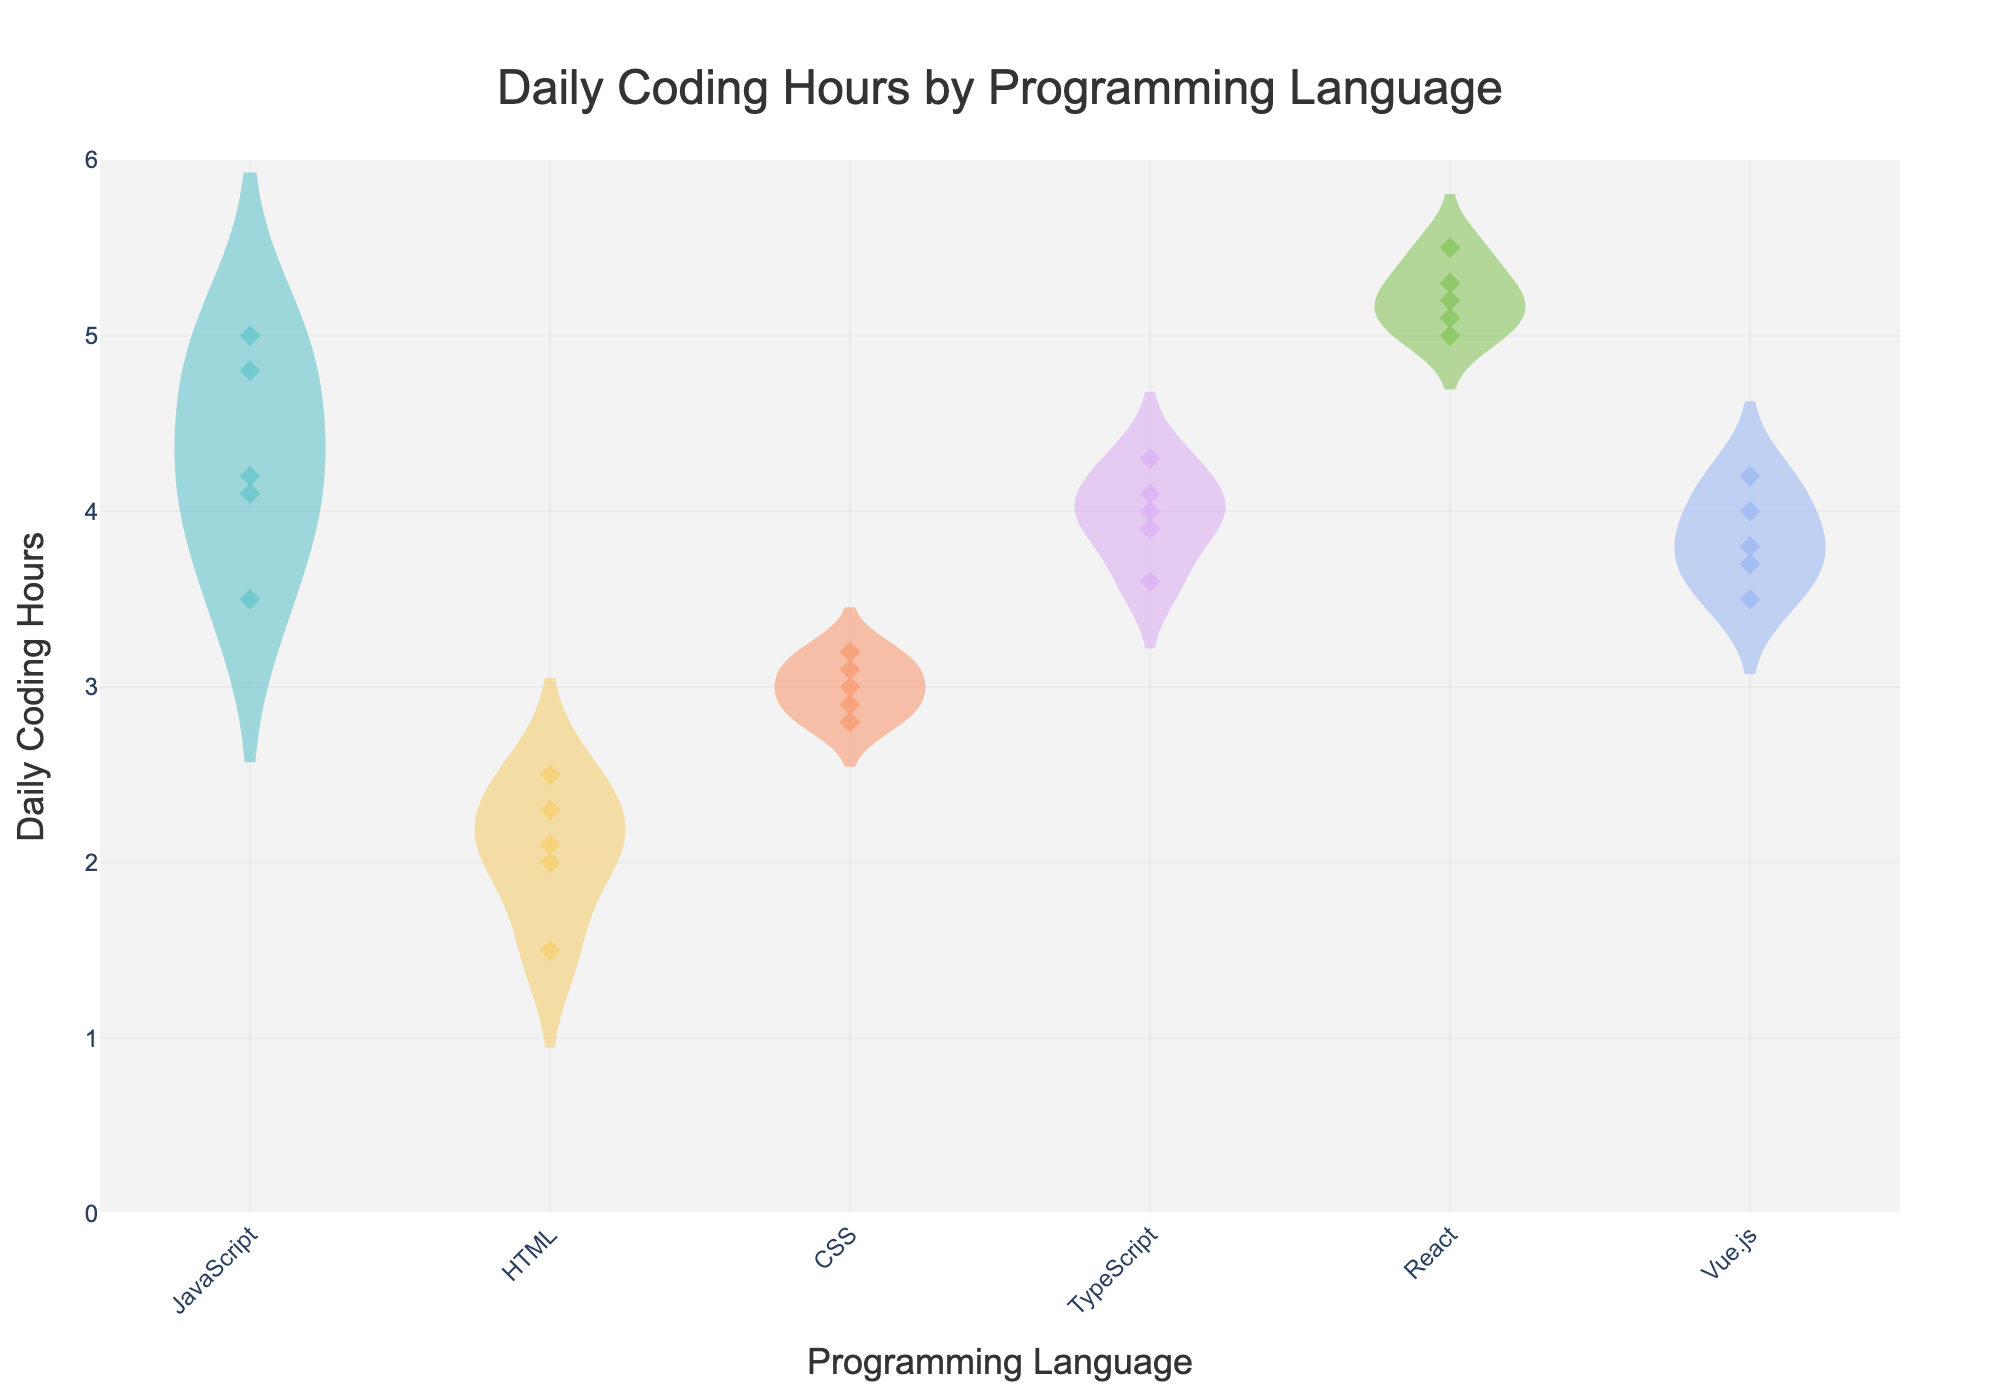What's the title of the figure? The title of the figure is displayed at the top center. It reads "Daily Coding Hours by Programming Language".
Answer: Daily Coding Hours by Programming Language Which programming language(s) has the highest median daily coding hours? The median daily coding hours are visualized by the horizontal line inside the violin plot. The React programming language's violin plot has the highest horizontal line indicating the highest median value.
Answer: React How many data points are there for JavaScript? Each dot represents a data point. Counting the dots for JavaScript, we see there are five dots.
Answer: 5 What is the range of daily coding hours for Vue.js? The range in the violin plot is the difference between the maximum and minimum values. For Vue.js, the violin plot extends from around 3.5 to 4.2 daily coding hours.
Answer: 3.5 to 4.2 Which programming language has the widest distribution of daily coding hours? The width of the violin plot indicates the distribution range. React has the widest distribution of daily coding hours compared to other languages.
Answer: React What is the average (mean) of daily coding hours for HTML? The average (mean) is visually indicated by the dashed line inside the violin plot. For HTML, this dashed line appears around 2.1 daily coding hours.
Answer: 2.1 Which programming language's daily coding hours are most evenly distributed? An even distribution is indicated by a symmetrical violin plot around the center. The violin plot for CSS appears most symmetrical around the mean line, indicating an even distribution.
Answer: CSS Are there any outliers for TypeScript daily coding hours? Outliers would be data points that fall outside the box in the violin plot. For TypeScript, there are no points outside its box, indicating no outliers.
Answer: No 